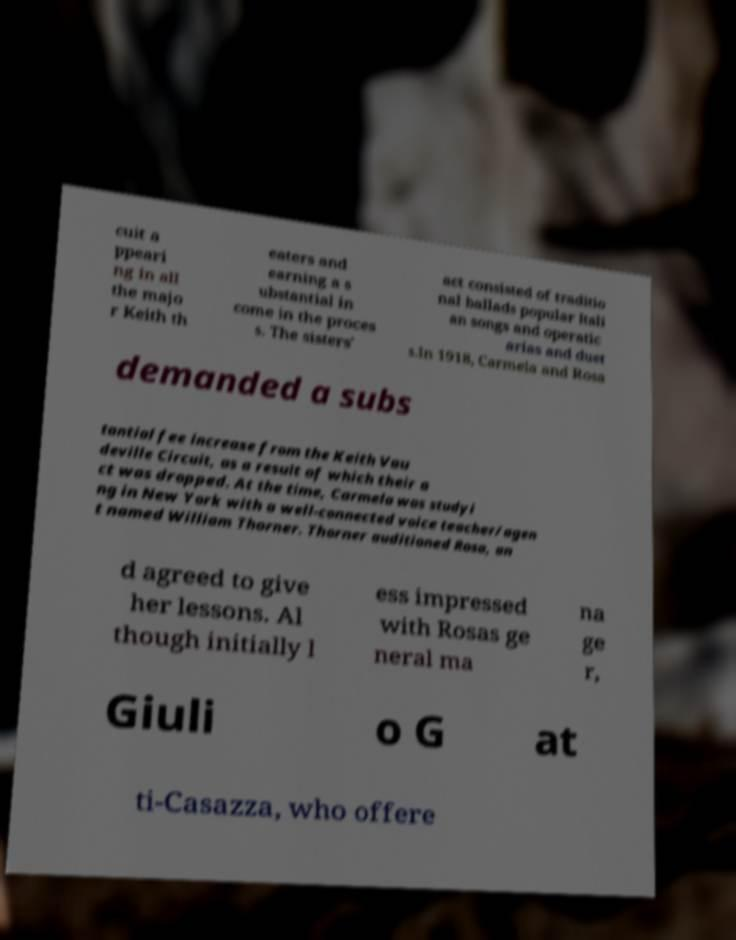Can you accurately transcribe the text from the provided image for me? cuit a ppeari ng in all the majo r Keith th eaters and earning a s ubstantial in come in the proces s. The sisters' act consisted of traditio nal ballads popular Itali an songs and operatic arias and duet s.In 1918, Carmela and Rosa demanded a subs tantial fee increase from the Keith Vau deville Circuit, as a result of which their a ct was dropped. At the time, Carmela was studyi ng in New York with a well-connected voice teacher/agen t named William Thorner. Thorner auditioned Rosa, an d agreed to give her lessons. Al though initially l ess impressed with Rosas ge neral ma na ge r, Giuli o G at ti-Casazza, who offere 